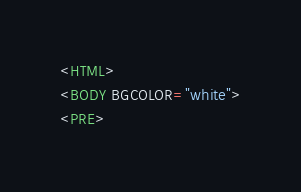<code> <loc_0><loc_0><loc_500><loc_500><_HTML_><HTML>
<BODY BGCOLOR="white">
<PRE></code> 